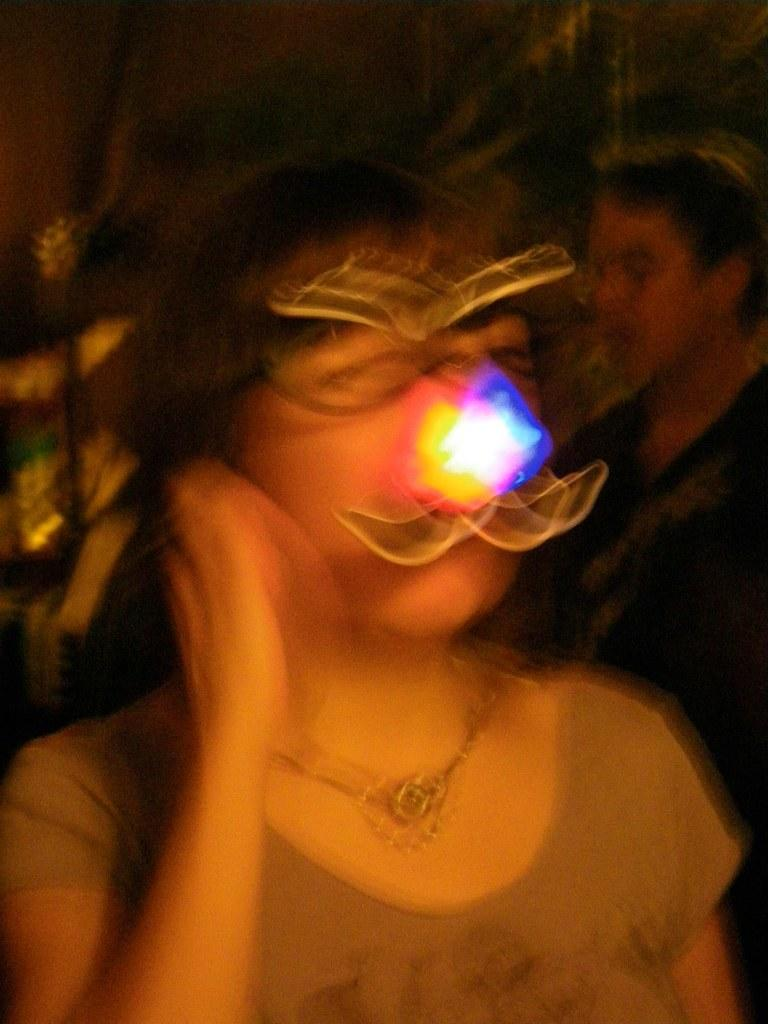How many people are present in the image? There are two people standing in the image. What type of pets are the people holding in the image? There are no pets visible in the image; only two people are present. 